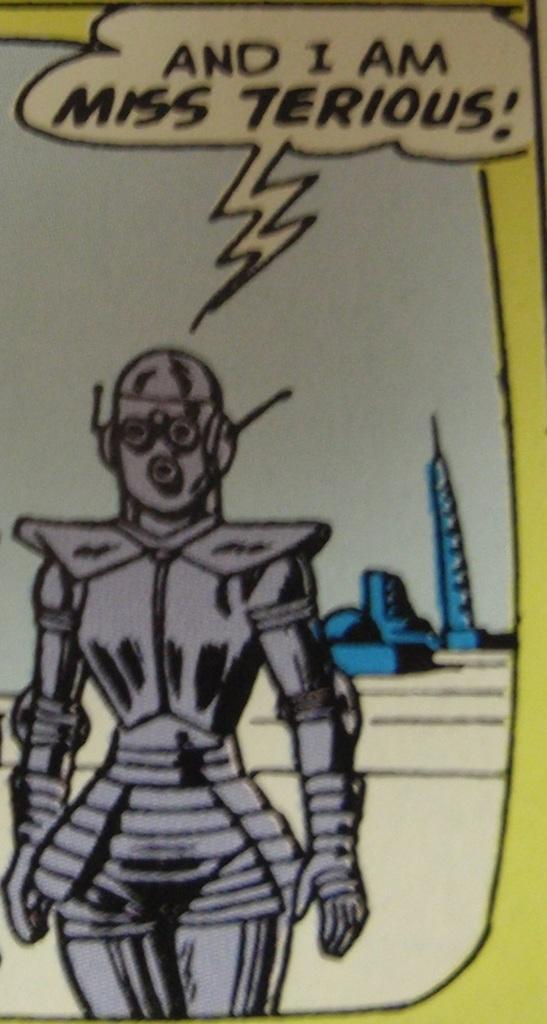Describe this image in one or two sentences. It is an animated pic, which looks like a robot in the shape of a woman. At the top it is the sky. 